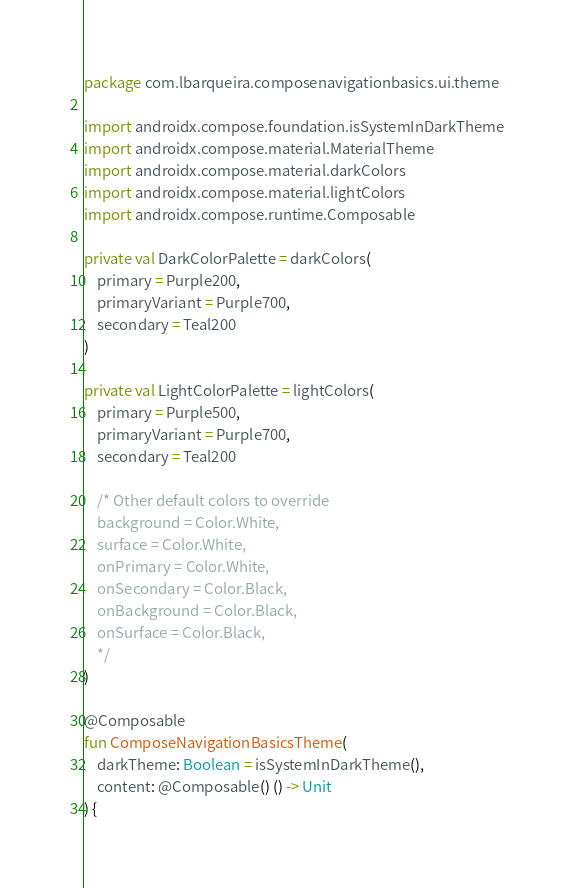<code> <loc_0><loc_0><loc_500><loc_500><_Kotlin_>package com.lbarqueira.composenavigationbasics.ui.theme

import androidx.compose.foundation.isSystemInDarkTheme
import androidx.compose.material.MaterialTheme
import androidx.compose.material.darkColors
import androidx.compose.material.lightColors
import androidx.compose.runtime.Composable

private val DarkColorPalette = darkColors(
    primary = Purple200,
    primaryVariant = Purple700,
    secondary = Teal200
)

private val LightColorPalette = lightColors(
    primary = Purple500,
    primaryVariant = Purple700,
    secondary = Teal200

    /* Other default colors to override
    background = Color.White,
    surface = Color.White,
    onPrimary = Color.White,
    onSecondary = Color.Black,
    onBackground = Color.Black,
    onSurface = Color.Black,
    */
)

@Composable
fun ComposeNavigationBasicsTheme(
    darkTheme: Boolean = isSystemInDarkTheme(),
    content: @Composable() () -> Unit
) {</code> 